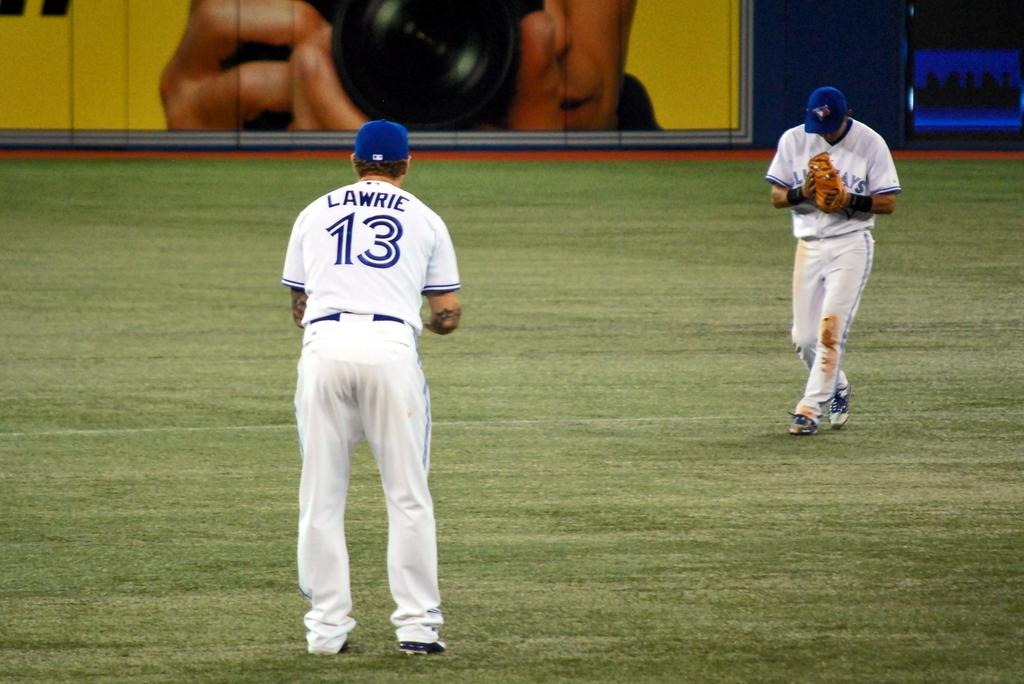<image>
Summarize the visual content of the image. a man in a Lawrie 13 baseball jersey looks at another on the field 